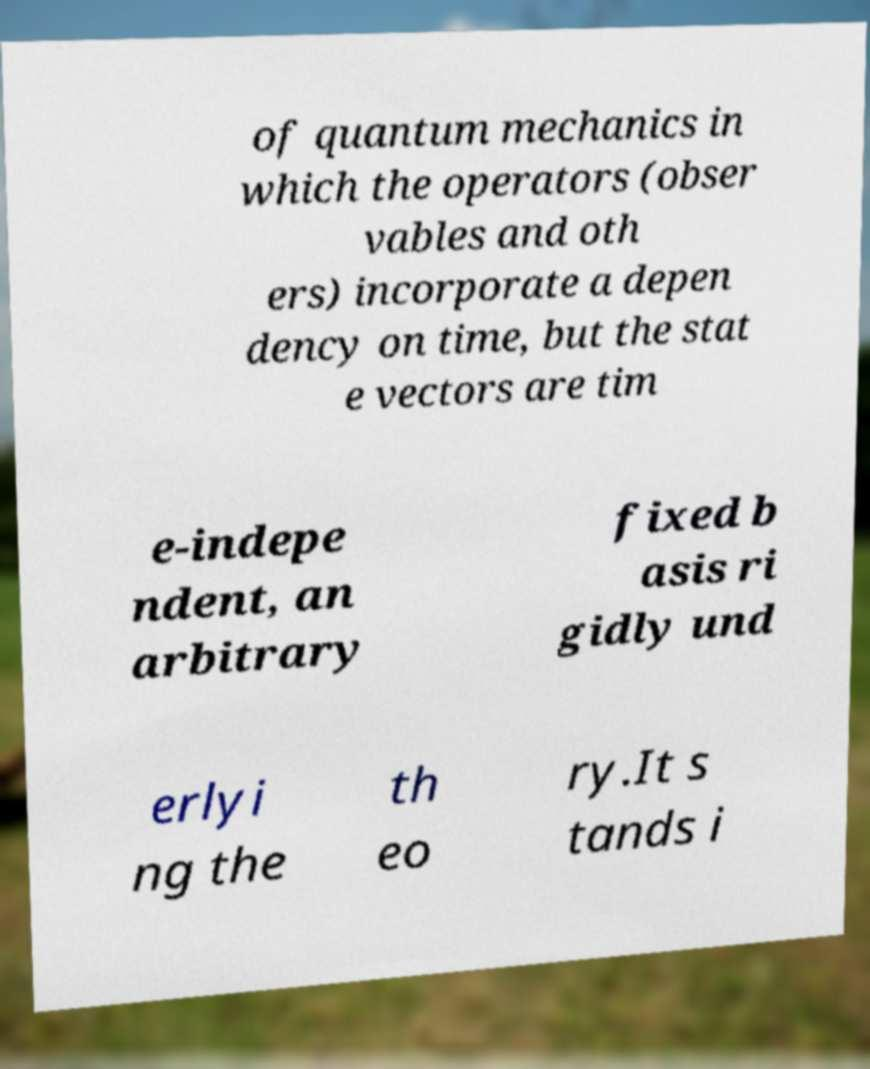For documentation purposes, I need the text within this image transcribed. Could you provide that? of quantum mechanics in which the operators (obser vables and oth ers) incorporate a depen dency on time, but the stat e vectors are tim e-indepe ndent, an arbitrary fixed b asis ri gidly und erlyi ng the th eo ry.It s tands i 